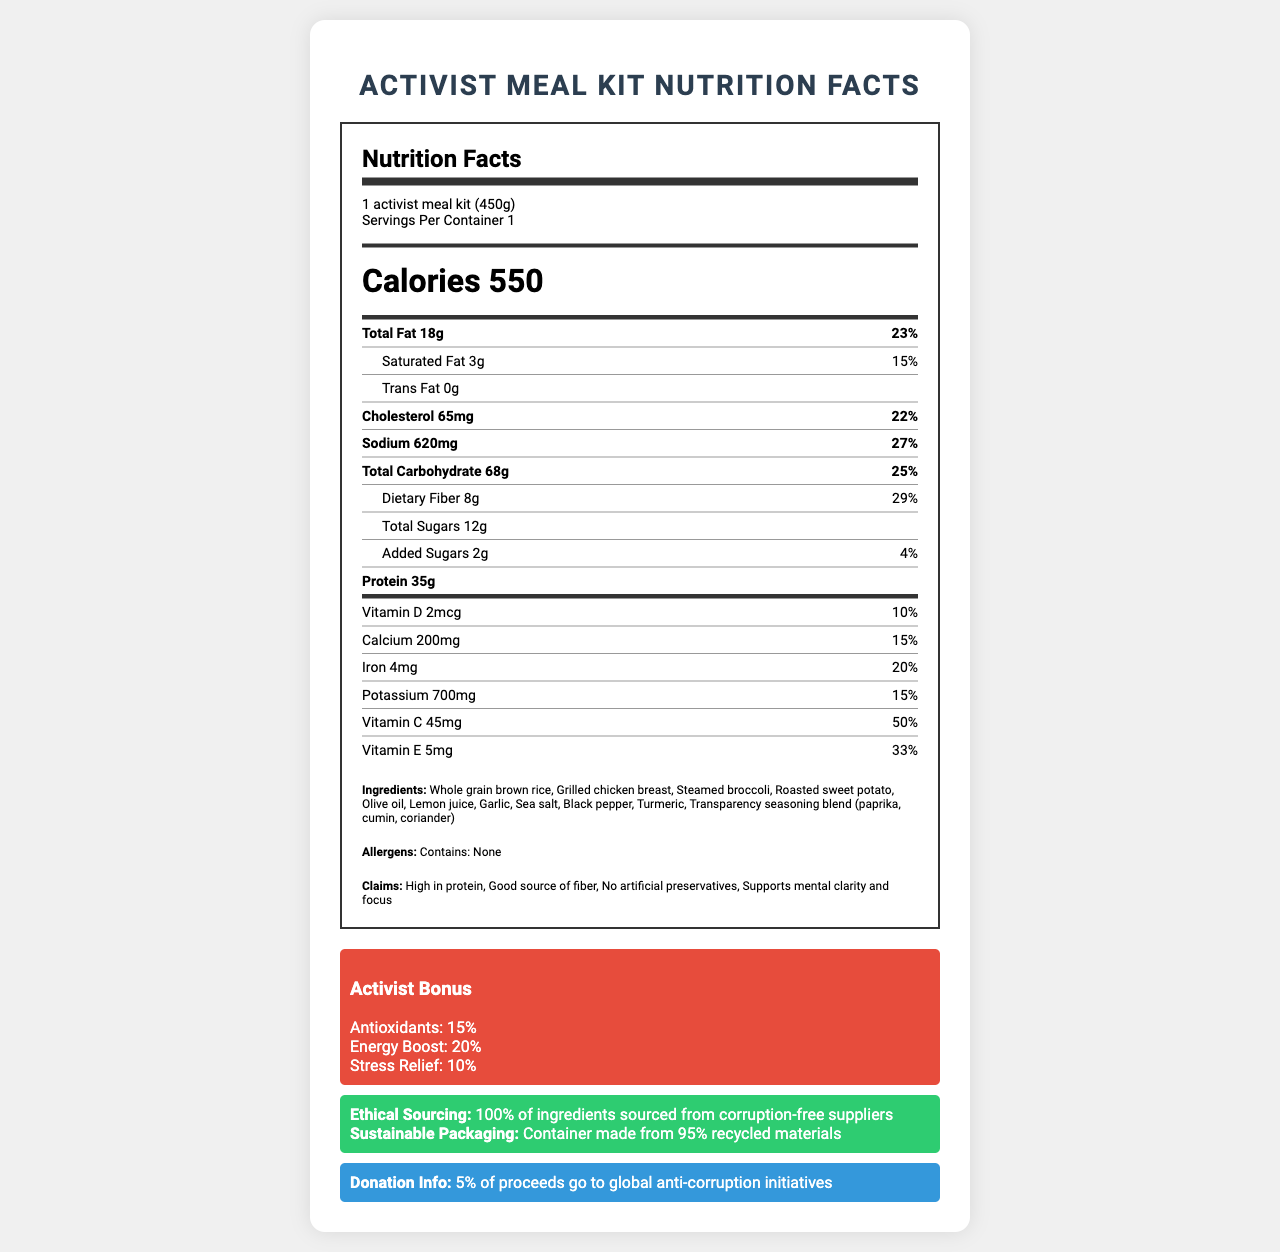what is the serving size of the meal kit? The document explicitly states the serving size is "1 activist meal kit (450g)."
Answer: 1 activist meal kit (450g) how many calories are in one serving of the meal kit? The document states that there are 550 calories per serving.
Answer: 550 calories What is the amount of total fat in the meal kit? The total fat amount is given as 18g in the document.
Answer: 18g What ingredients are used in this meal kit? The ingredients are listed explicitly in the document.
Answer: Whole grain brown rice, Grilled chicken breast, Steamed broccoli, Roasted sweet potato, Olive oil, Lemon juice, Garlic, Sea salt, Black pepper, Turmeric, Transparency seasoning blend (paprika, cumin, coriander) How many grams of protein does the meal kit contain? The document states that the meal kit contains 35 grams of protein.
Answer: 35g Which of the following vitamins does the meal kit contain the most of? A. Vitamin D B. Vitamin C C. Vitamin E D. Calcium The document contains 45mg of Vitamin C, which is the highest among the provided vitamins.
Answer: B. Vitamin C Which nutrient has the highest daily value percentage in the meal kit? A. Sodium B. Dietary Fiber C. Total Carbohydrate D. Iron Total Carbohydrate has a daily value of 25%, which is tied with Dietary Fiber for the highest, but since it's listed first, we infer it's prioritized.
Answer: C. Total Carbohydrate Does the meal kit contain artificial preservatives? One of the claim statements is "No artificial preservatives."
Answer: No Summarize the main idea of the document. The summary covers the key sections: nutritional values, health benefits, ethical sourcing, and charitable contributions.
Answer: The document provides the nutrition facts for a healthy meal kit designed for anti-corruption activists, highlighting its high protein content, ethical sourcing, sustainable packaging, and donations to global anti-corruption initiatives. What is the purpose of the activist bonus section? The special "Activist Bonus" section indicates tailored benefits for activists.
Answer: The activist bonus section highlights additional health benefits such as antioxidants, energy boost, and stress relief. From where are the ingredients sourced? The ethical sourcing information clearly states that all ingredients are corruption-free sourced.
Answer: 100% of ingredients sourced from corruption-free suppliers What does the sodium content of the meal kit represent in terms of daily value percentage? The sodium content in the meal kit represents 27% of the daily value.
Answer: 27% Is this meal kit a good source of fiber? The document states that the meal kit is a "Good source of fiber."
Answer: Yes Where are the containers for the meal kit made from? The sustainable packaging section mentions the container is made from 95% recycled materials.
Answer: 95% recycled materials How many grams of added sugars are in the meal kit? The document states that there are 2 grams of added sugars in the meal kit.
Answer: 2g What form of packaging does the meal come in? A. Plastic B. Glass C. Recycled materials D. Biodegradable materials The document mentions that the container is made from 95% recycled materials.
Answer: C. Recycled materials How much of the meal kit proceeds go to anti-corruption initiatives? The donation information states that 5% of the proceeds go to global anti-corruption initiatives.
Answer: 5% What is the total carbohydrate content in grams? The document lists the total carbohydrate amount as 68 grams.
Answer: 68g Can the meal kit be consumed by people with allergies? The document explicitly states that the allergens section contains "None."
Answer: Contains: None What is the total amount of Vitamin E in the meal kit? The document states that there is 5mg of Vitamin E in the meal kit.
Answer: 5mg What is the daily value percentage of calcium in the meal kit? The document lists the daily value percentage of calcium as 15%.
Answer: 15% Does the meal kit support mental clarity and focus? One of the claim statements is that the meal kit "Supports mental clarity and focus."
Answer: Yes How is the ethical sourcing of ingredients ensured? The document states the ingredients are sourced from corruption-free suppliers but does not provide details on how this is ensured.
Answer: Cannot be determined 